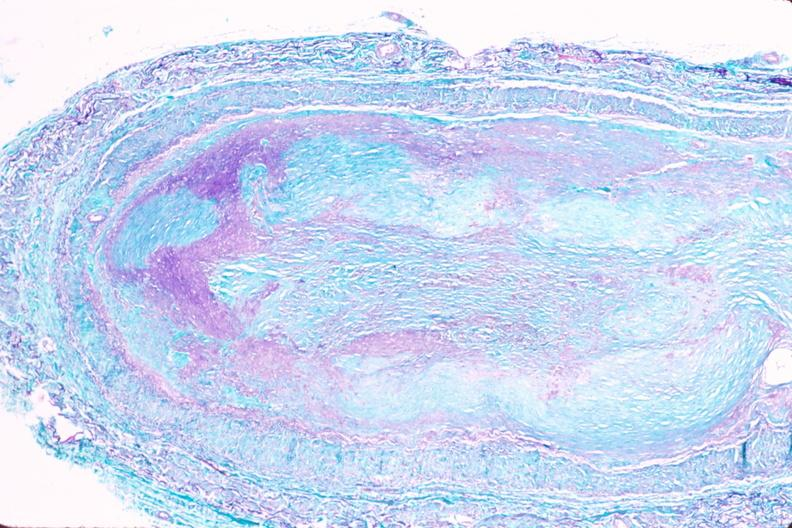what is present?
Answer the question using a single word or phrase. Vasculature 